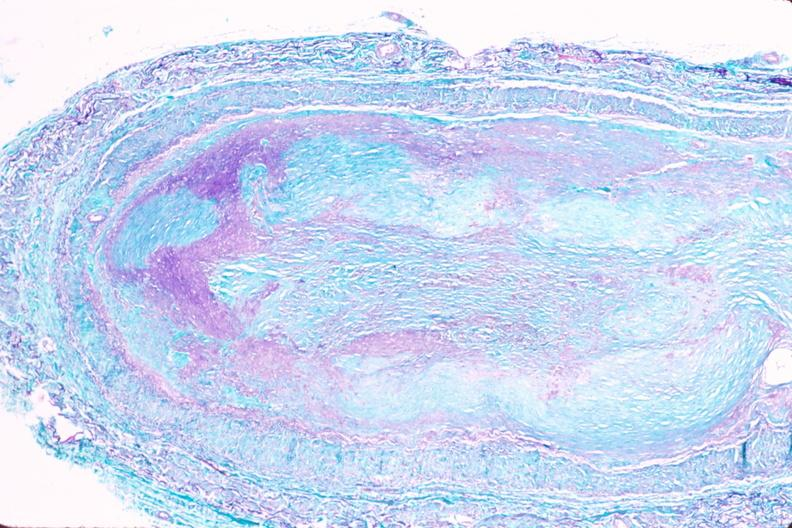what is present?
Answer the question using a single word or phrase. Vasculature 